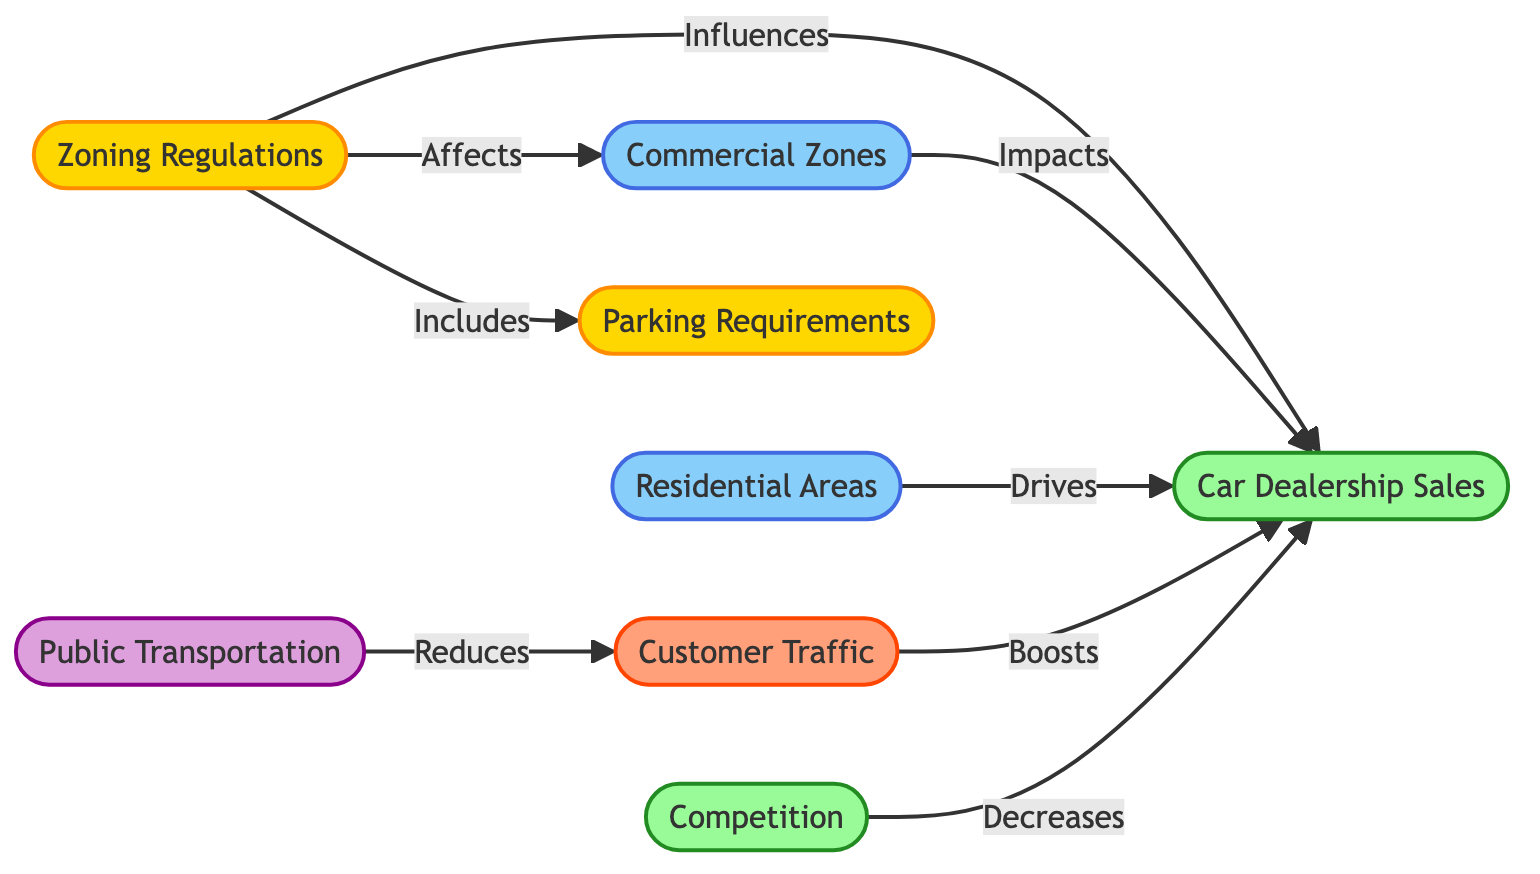What are the types of nodes present in the diagram? The diagram includes the following types of nodes: policy, sales, area, traffic, and infrastructure. These types categorize the different aspects influencing car dealership sales.
Answer: policy, sales, area, traffic, infrastructure How many total nodes are there in the diagram? By counting the unique identifiers in the "nodes" section, we find there are a total of eight nodes: zoning regulations, car dealership sales, residential areas, commercial zones, parking requirements, customer traffic, public transportation, and competition.
Answer: eight What relationship does zoning regulations have with commercial zones? The edge between zoning regulations and commercial zones is labeled "Affects," indicating that zoning regulations have an influence on the establishment or characteristics of commercial zones.
Answer: Affects Which node is directly influenced by customer traffic? There is a direct edge labeled "Boosts" from the customer traffic node to the car dealership sales node, indicating that an increase in customer traffic positively impacts car dealership sales.
Answer: car dealership sales How does public transportation relate to customer traffic? The diagram shows that public transportation "Reduces" customer traffic, indicating that improved public transport may lead to fewer customers arriving by private vehicles, affecting the traffic levels.
Answer: Reduces What impacts car dealership sales according to the diagram? The car dealership sales node is influenced by several other nodes, including zoning regulations, commercial zones, residential areas, customer traffic, and competition, which show a variety of factors affecting sales.
Answer: zoning regulations, commercial zones, residential areas, customer traffic, competition Which two factors lead to higher car dealership sales? The factors that contribute positively to car dealership sales as indicated in the diagram are increased customer traffic and favorable zoning regulations, which are both connected by edges labeled "Boosts" and "Influences," respectively.
Answer: customer traffic, zoning regulations What effect does competition have on car dealership sales? The competition node has an edge leading to car dealership sales labeled "Decreases," indicating that higher competition among dealerships tends to negatively affect sales numbers.
Answer: Decreases How many edges are connected to car dealership sales? By inspecting the edges related to the car dealership sales node, we see that it has connections from five nodes - zoning regulations, commercial zones, residential areas, customer traffic, and competition, making a total of five edges.
Answer: five What is the relationship between parking requirements and zoning regulations? The edge between parking requirements and zoning regulations is labeled "Includes," which indicates that parking requirements are a component of the broader zoning regulations.
Answer: Includes 